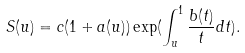Convert formula to latex. <formula><loc_0><loc_0><loc_500><loc_500>S ( u ) = c ( 1 + a ( u ) ) \exp ( \int _ { u } ^ { 1 } \frac { b ( t ) } { t } d t ) .</formula> 